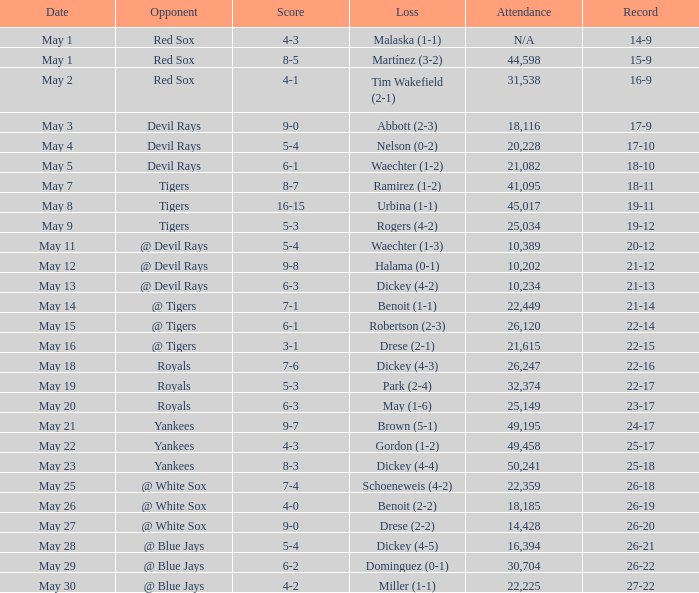What was the record at the game attended by 10,389? 20-12. 